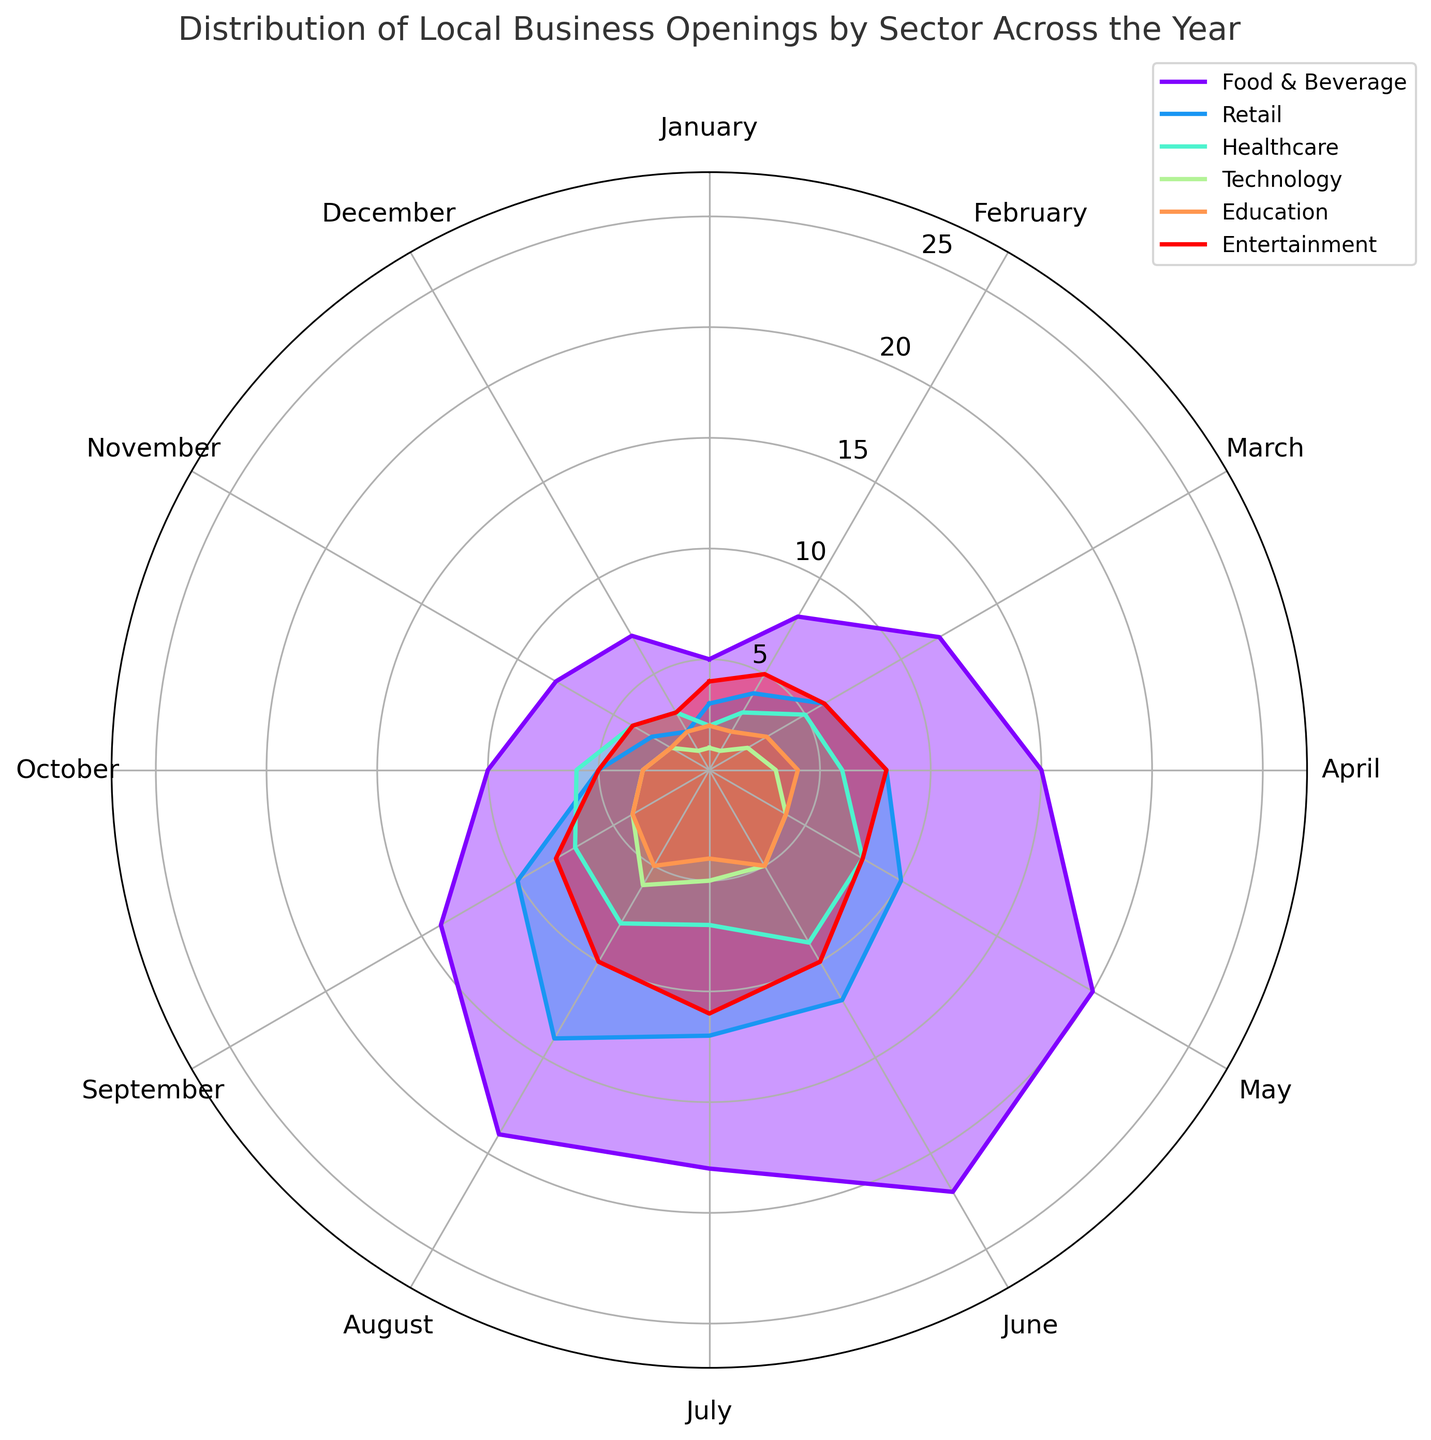Which sector has the highest number of business openings in May? Look for the sector with the longest bar in May on the rose chart. The Food & Beverage sector has the longest bar in May, indicating 20 business openings.
Answer: Food & Beverage Which month has the fewest business openings for the Technology sector? Identify the points for the Technology sector and note the heights of bars for each month. The shortest bars for the Technology sector are in January, February, November, and December, each with 1 business opening.
Answer: January, February, November, December How do the business openings in July compare between the Healthcare and Entertainment sectors? Look at the heights of the bars for July in the Healthcare and Entertainment sectors. Healthcare has a height indicating 7 business openings, while Entertainment has 11 business openings.
Answer: Entertainment > Healthcare What is the total number of business openings in Food & Beverage and Retail sectors in June? Sum the heights of the bars for Food & Beverage and Retail sectors in June. Food & Beverage has 22 and Retail has 12 openings. Therefore, the total is 22 + 12 = 34.
Answer: 34 What's the month with the highest number of business openings for the Entertainment sector? Identify the highest point for the Entertainment sector. The highest bar for Entertainment is in July, indicating 11 business openings.
Answer: July Which sector has a more consistent trend of business openings across all months, and how do you determine this? Compare the variance in the lengths of the bars for each sector. The Technology sector has bars of similar and smaller heights throughout the year, indicating a more consistent trend.
Answer: Technology What’s the difference in business openings between the peak month and the lowest month for the Retail sector? Identify the highest and lowest points for the Retail sector. The highest is in August with 14 openings, and the lowest is in December with 2 openings. The difference is 14 - 2 = 12.
Answer: 12 How does the number of business openings in December compare between Food & Beverage and Healthcare sectors? Compare the heights of the bars in December for both sectors. Food & Beverage has 7 openings, and Healthcare has 3 openings.
Answer: Food & Beverage > Healthcare 